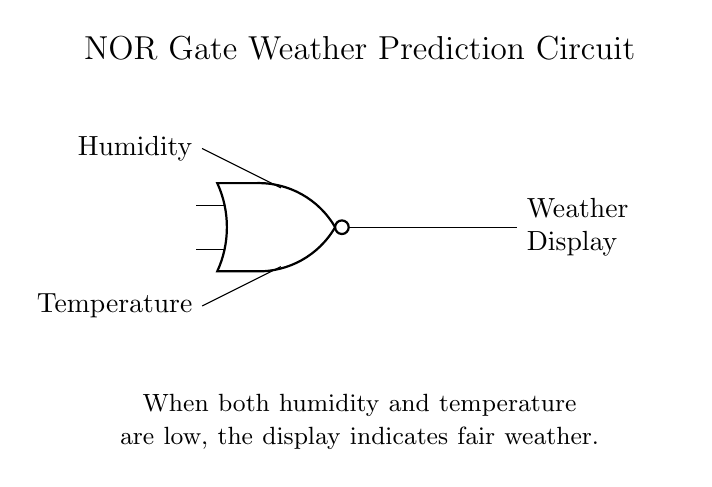What type of logic gate is used in this circuit? The circuit diagram clearly shows a NOR gate as the primary component, indicated by the specific symbol used.
Answer: NOR gate What are the two inputs to the NOR gate? The inputs are labeled as Humidity and Temperature, which are connected to the NOR gate.
Answer: Humidity and Temperature What happens when both inputs are high? The behavior of a NOR gate indicates that when both inputs are high, the output will be low, which means the weather display will not show fair weather.
Answer: Low What does the weather display indicate when both inputs are low? According to the explanatory text, when both humidity and temperature are low, the display indicates fair weather.
Answer: Fair weather How many inputs does the NOR gate have? The symbol for the NOR gate shows that it has two inputs, each corresponding to the Humidity and Temperature.
Answer: Two What is the main function of the circuit? The circuit's main function is to predict weather conditions based on the input readings of humidity and temperature.
Answer: Weather prediction What will the output be if humidity is low and temperature is high? Since the NOR gate outputs high only when both inputs are low, if humidity is low and temperature is high, the output will still be low.
Answer: Low 